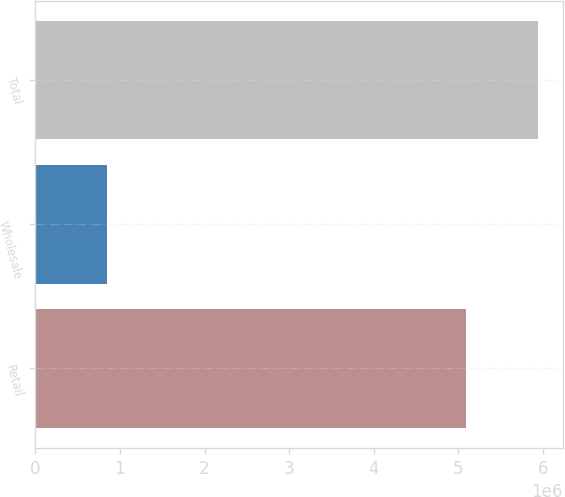Convert chart. <chart><loc_0><loc_0><loc_500><loc_500><bar_chart><fcel>Retail<fcel>Wholesale<fcel>Total<nl><fcel>5.09462e+06<fcel>844033<fcel>5.93865e+06<nl></chart> 